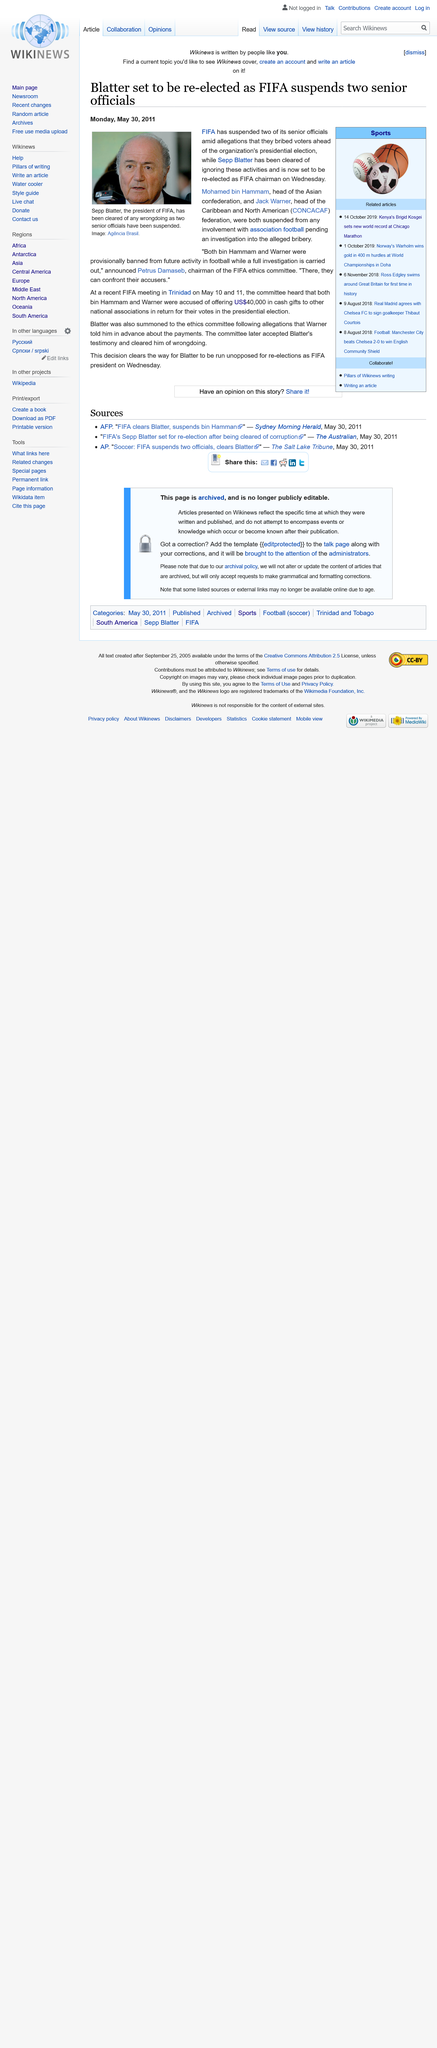Highlight a few significant elements in this photo. Petrus Damaseb was the chairman of the FIFA ethics committee during the 2011 bribery scandal. In 2011, Jack Warner was the head of the Caribbean and North America federation, which was involved in alleged bribery. Mohamed bin Hammam was the head of the Asian confederation involved in alleged bribery in 2011. 